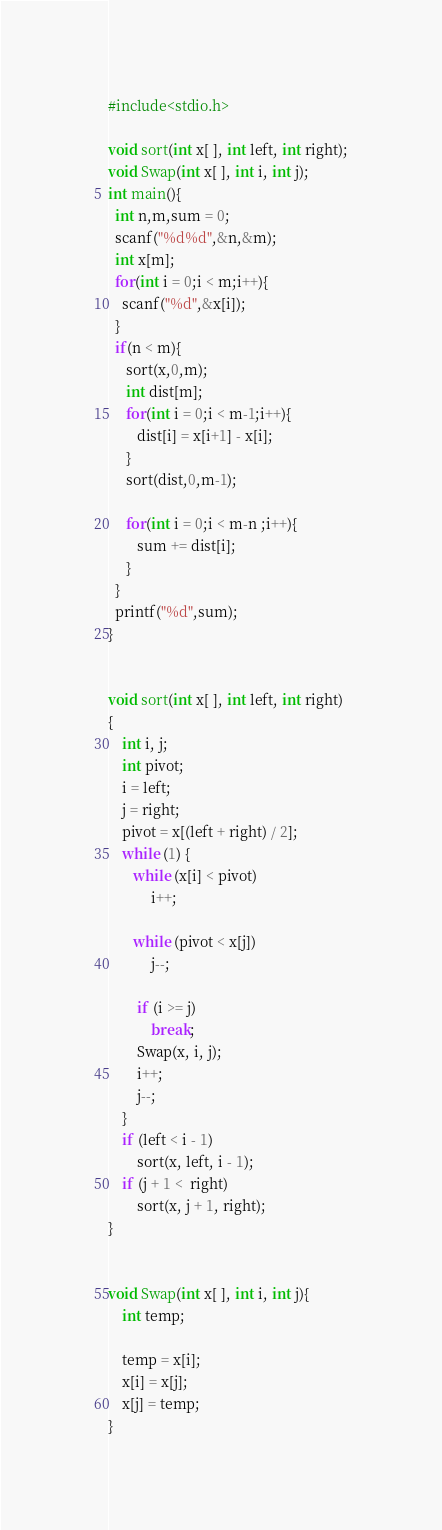<code> <loc_0><loc_0><loc_500><loc_500><_C_>#include<stdio.h>

void sort(int x[ ], int left, int right);
void Swap(int x[ ], int i, int j);
int main(){
  int n,m,sum = 0;
  scanf("%d%d",&n,&m);
  int x[m];
  for(int i = 0;i < m;i++){
    scanf("%d",&x[i]);
  }
  if(n < m){
     sort(x,0,m);
     int dist[m];
     for(int i = 0;i < m-1;i++){  
        dist[i] = x[i+1] - x[i];
     }   
     sort(dist,0,m-1);

     for(int i = 0;i < m-n ;i++){
        sum += dist[i];
     }
  }
  printf("%d",sum);
}  
      

void sort(int x[ ], int left, int right)
{
    int i, j;
    int pivot;
    i = left;                     
    j = right;                     
    pivot = x[(left + right) / 2]; 
    while (1) {     
       while (x[i] < pivot)     
            i++;
       
       while (pivot < x[j])  
            j--;
       
        if (i >= j)               
            break;                 
        Swap(x, i, j);             
        i++;                      
        j--;
    }           
    if (left < i - 1)              
        sort(x, left, i - 1);     
    if (j + 1 <  right)            
        sort(x, j + 1, right);    
}

  
void Swap(int x[ ], int i, int j){
    int temp;

    temp = x[i];
    x[i] = x[j];
    x[j] = temp;
}
</code> 